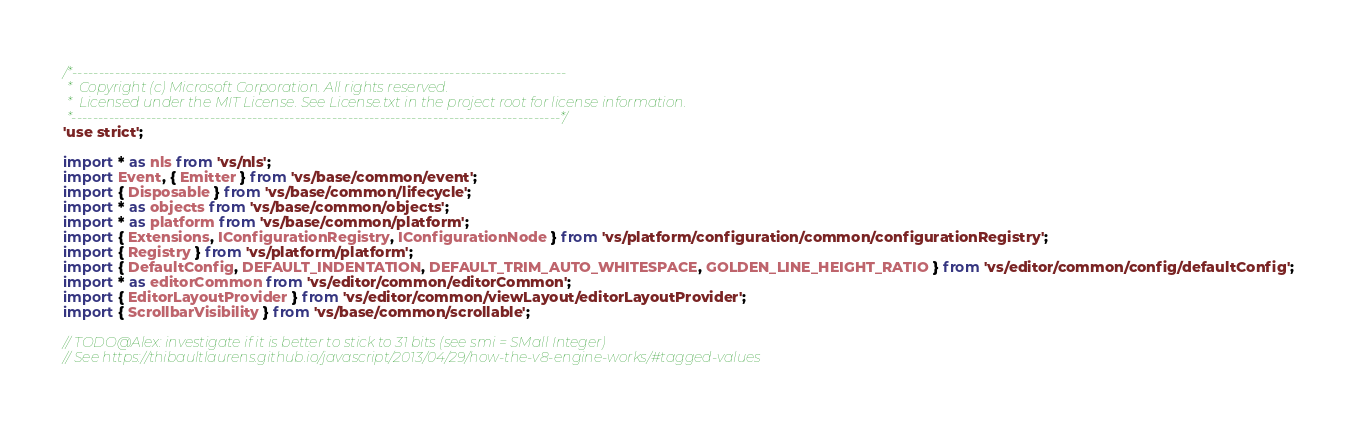Convert code to text. <code><loc_0><loc_0><loc_500><loc_500><_TypeScript_>/*---------------------------------------------------------------------------------------------
 *  Copyright (c) Microsoft Corporation. All rights reserved.
 *  Licensed under the MIT License. See License.txt in the project root for license information.
 *--------------------------------------------------------------------------------------------*/
'use strict';

import * as nls from 'vs/nls';
import Event, { Emitter } from 'vs/base/common/event';
import { Disposable } from 'vs/base/common/lifecycle';
import * as objects from 'vs/base/common/objects';
import * as platform from 'vs/base/common/platform';
import { Extensions, IConfigurationRegistry, IConfigurationNode } from 'vs/platform/configuration/common/configurationRegistry';
import { Registry } from 'vs/platform/platform';
import { DefaultConfig, DEFAULT_INDENTATION, DEFAULT_TRIM_AUTO_WHITESPACE, GOLDEN_LINE_HEIGHT_RATIO } from 'vs/editor/common/config/defaultConfig';
import * as editorCommon from 'vs/editor/common/editorCommon';
import { EditorLayoutProvider } from 'vs/editor/common/viewLayout/editorLayoutProvider';
import { ScrollbarVisibility } from 'vs/base/common/scrollable';

// TODO@Alex: investigate if it is better to stick to 31 bits (see smi = SMall Integer)
// See https://thibaultlaurens.github.io/javascript/2013/04/29/how-the-v8-engine-works/#tagged-values</code> 